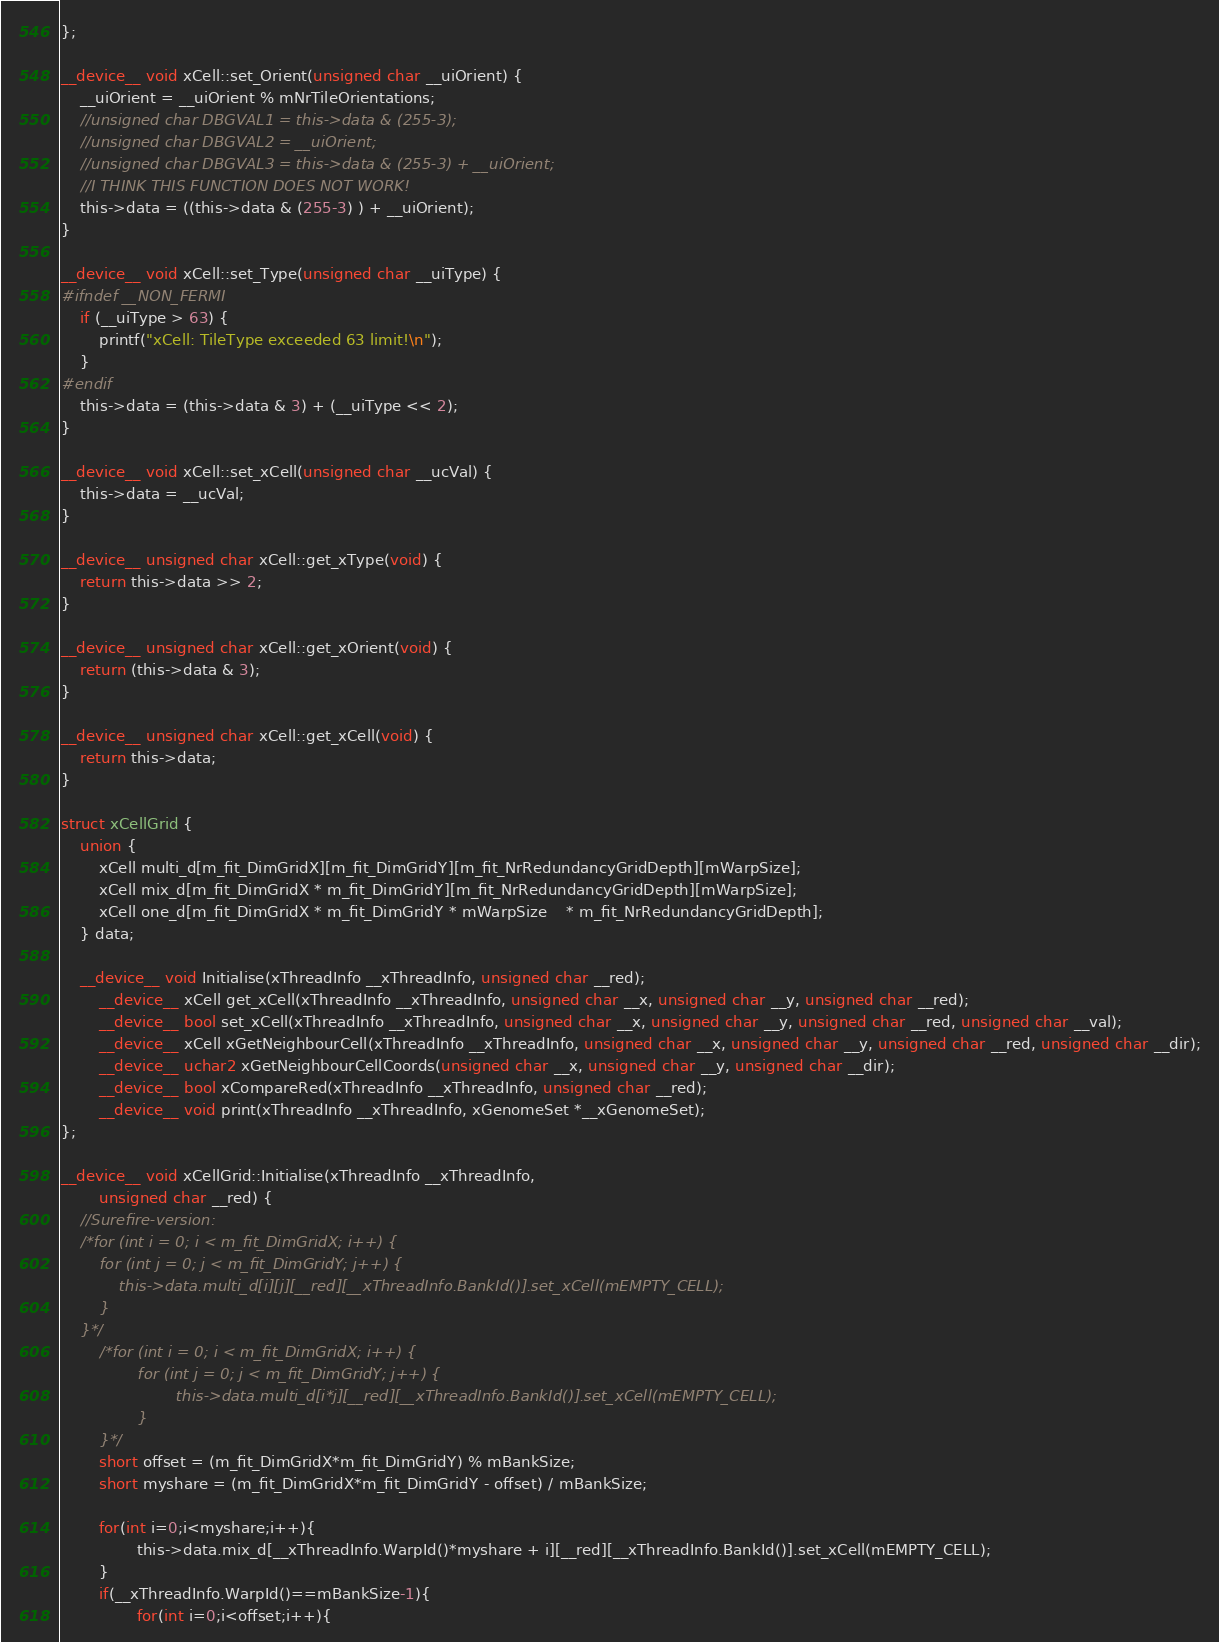Convert code to text. <code><loc_0><loc_0><loc_500><loc_500><_Cuda_>};

__device__ void xCell::set_Orient(unsigned char __uiOrient) {
	__uiOrient = __uiOrient % mNrTileOrientations;
	//unsigned char DBGVAL1 = this->data & (255-3);
	//unsigned char DBGVAL2 = __uiOrient;
	//unsigned char DBGVAL3 = this->data & (255-3) + __uiOrient;
	//I THINK THIS FUNCTION DOES NOT WORK!
	this->data = ((this->data & (255-3) ) + __uiOrient);
}

__device__ void xCell::set_Type(unsigned char __uiType) {
#ifndef __NON_FERMI
	if (__uiType > 63) {
		printf("xCell: TileType exceeded 63 limit!\n");
	}
#endif
	this->data = (this->data & 3) + (__uiType << 2);
}

__device__ void xCell::set_xCell(unsigned char __ucVal) {
	this->data = __ucVal;
}

__device__ unsigned char xCell::get_xType(void) {
	return this->data >> 2;
}

__device__ unsigned char xCell::get_xOrient(void) {
	return (this->data & 3);
}

__device__ unsigned char xCell::get_xCell(void) {
	return this->data;
}

struct xCellGrid {
	union {
		xCell multi_d[m_fit_DimGridX][m_fit_DimGridY][m_fit_NrRedundancyGridDepth][mWarpSize];
		xCell mix_d[m_fit_DimGridX * m_fit_DimGridY][m_fit_NrRedundancyGridDepth][mWarpSize];
		xCell one_d[m_fit_DimGridX * m_fit_DimGridY * mWarpSize	* m_fit_NrRedundancyGridDepth];
	} data;

	__device__ void Initialise(xThreadInfo __xThreadInfo, unsigned char __red);
        __device__ xCell get_xCell(xThreadInfo __xThreadInfo, unsigned char __x, unsigned char __y, unsigned char __red);
        __device__ bool set_xCell(xThreadInfo __xThreadInfo, unsigned char __x, unsigned char __y, unsigned char __red, unsigned char __val);
        __device__ xCell xGetNeighbourCell(xThreadInfo __xThreadInfo, unsigned char __x, unsigned char __y, unsigned char __red, unsigned char __dir);
        __device__ uchar2 xGetNeighbourCellCoords(unsigned char __x, unsigned char __y, unsigned char __dir);
        __device__ bool xCompareRed(xThreadInfo __xThreadInfo, unsigned char __red);
        __device__ void print(xThreadInfo __xThreadInfo, xGenomeSet *__xGenomeSet);
};

__device__ void xCellGrid::Initialise(xThreadInfo __xThreadInfo,
		unsigned char __red) {
	//Surefire-version:
	/*for (int i = 0; i < m_fit_DimGridX; i++) {
		for (int j = 0; j < m_fit_DimGridY; j++) {
			this->data.multi_d[i][j][__red][__xThreadInfo.BankId()].set_xCell(mEMPTY_CELL);
		}
	}*/
        /*for (int i = 0; i < m_fit_DimGridX; i++) {
                for (int j = 0; j < m_fit_DimGridY; j++) {
                        this->data.multi_d[i*j][__red][__xThreadInfo.BankId()].set_xCell(mEMPTY_CELL);
                }
        }*/
        short offset = (m_fit_DimGridX*m_fit_DimGridY) % mBankSize;
        short myshare = (m_fit_DimGridX*m_fit_DimGridY - offset) / mBankSize; 

        for(int i=0;i<myshare;i++){
                this->data.mix_d[__xThreadInfo.WarpId()*myshare + i][__red][__xThreadInfo.BankId()].set_xCell(mEMPTY_CELL); 
        }
        if(__xThreadInfo.WarpId()==mBankSize-1){
                for(int i=0;i<offset;i++){</code> 